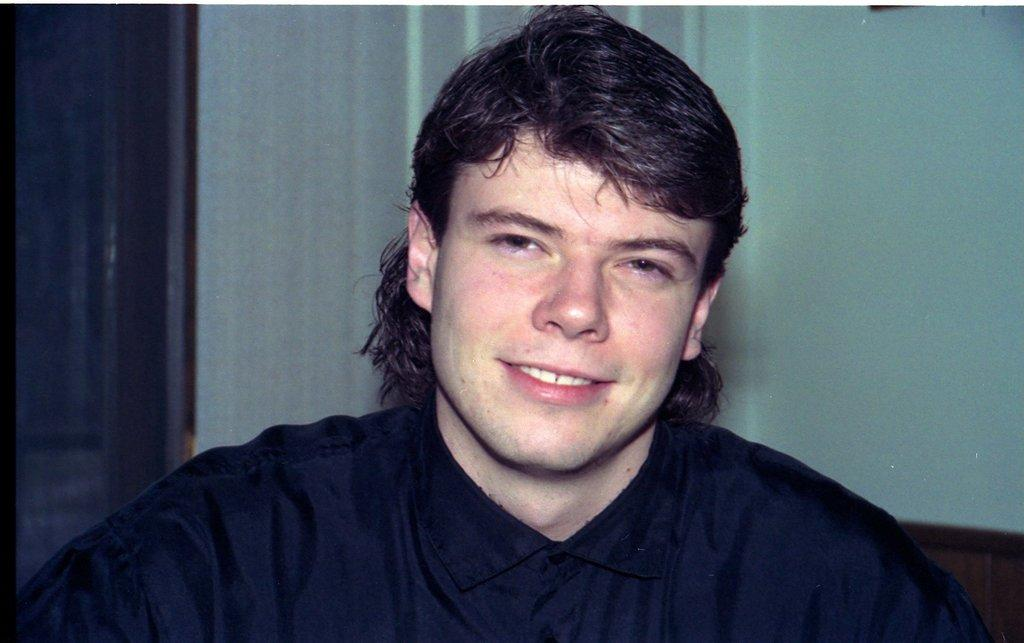Who is the main subject in the image? There is a man in the middle of the image. What can be seen in the background of the image? There is a wall in the background of the image. Is there any entrance or exit visible in the image? Yes, there appears to be a door on the right side of the image. What type of insect can be seen crawling on the man's shoulder in the image? There is no insect visible on the man's shoulder in the image. 